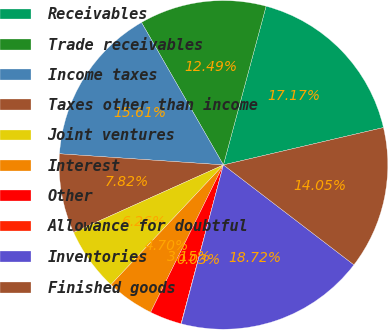<chart> <loc_0><loc_0><loc_500><loc_500><pie_chart><fcel>Receivables<fcel>Trade receivables<fcel>Income taxes<fcel>Taxes other than income<fcel>Joint ventures<fcel>Interest<fcel>Other<fcel>Allowance for doubtful<fcel>Inventories<fcel>Finished goods<nl><fcel>17.17%<fcel>12.49%<fcel>15.61%<fcel>7.82%<fcel>6.26%<fcel>4.7%<fcel>3.15%<fcel>0.03%<fcel>18.72%<fcel>14.05%<nl></chart> 